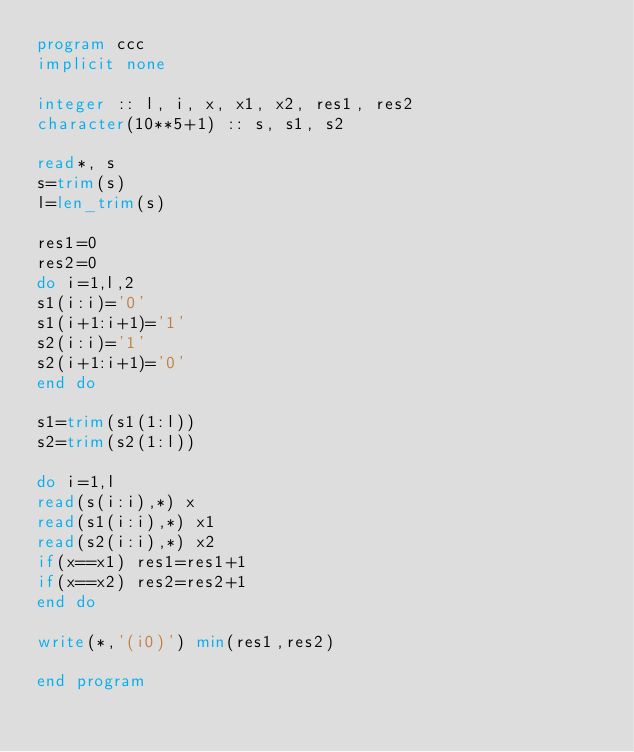Convert code to text. <code><loc_0><loc_0><loc_500><loc_500><_FORTRAN_>program ccc
implicit none

integer :: l, i, x, x1, x2, res1, res2
character(10**5+1) :: s, s1, s2

read*, s
s=trim(s)
l=len_trim(s)

res1=0
res2=0
do i=1,l,2
s1(i:i)='0'
s1(i+1:i+1)='1'
s2(i:i)='1'
s2(i+1:i+1)='0'
end do

s1=trim(s1(1:l))
s2=trim(s2(1:l))

do i=1,l
read(s(i:i),*) x
read(s1(i:i),*) x1
read(s2(i:i),*) x2
if(x==x1) res1=res1+1
if(x==x2) res2=res2+1
end do

write(*,'(i0)') min(res1,res2)

end program</code> 